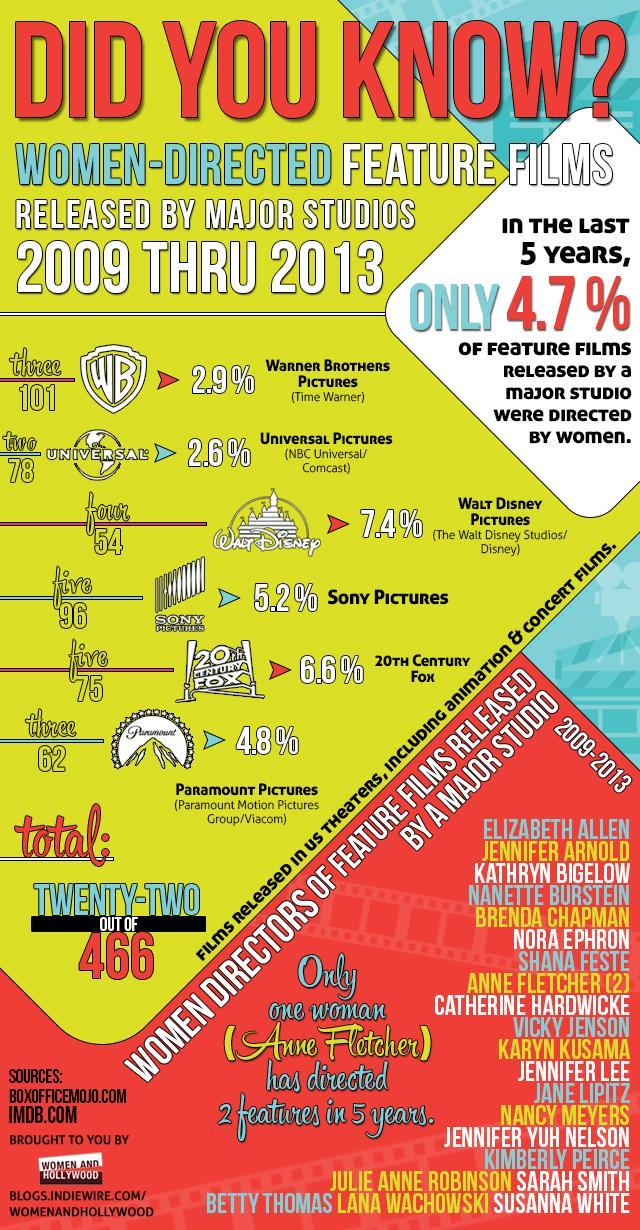Specify some key components in this picture. Only 4.7% of feature films released by a major studio in the last five years were directed by women. 